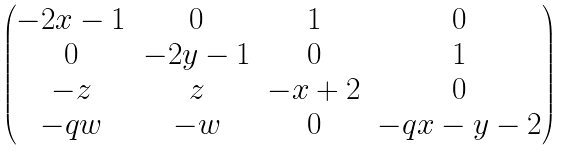Convert formula to latex. <formula><loc_0><loc_0><loc_500><loc_500>\begin{pmatrix} - 2 x - 1 & 0 & 1 & 0 \\ 0 & - 2 y - 1 & 0 & 1 \\ - z & z & - x + 2 & 0 \\ - q w & - w & 0 & - q x - y - 2 \end{pmatrix}</formula> 